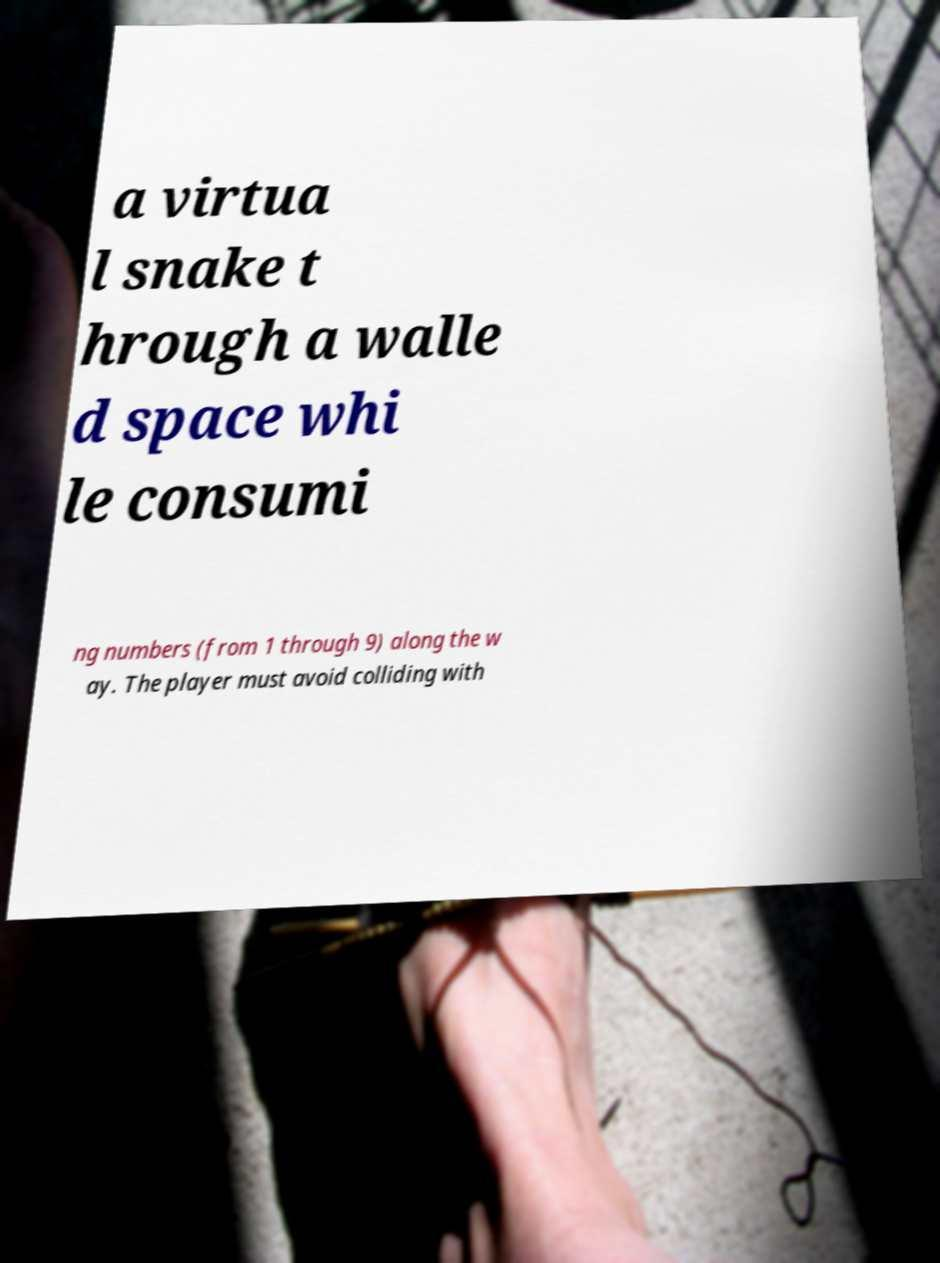Can you read and provide the text displayed in the image?This photo seems to have some interesting text. Can you extract and type it out for me? a virtua l snake t hrough a walle d space whi le consumi ng numbers (from 1 through 9) along the w ay. The player must avoid colliding with 